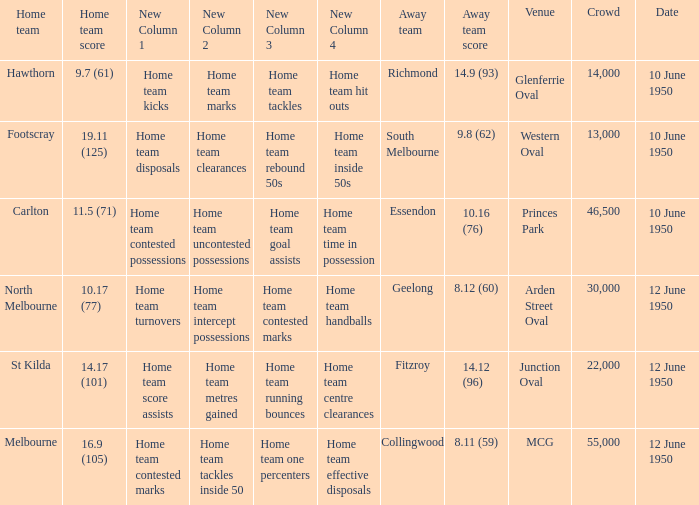What was the size of the audience when the vfl took place at mcg? 55000.0. 